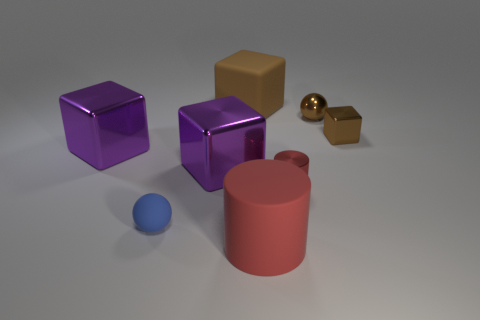Describe the lighting and atmosphere of this scene. The lighting in the scene is soft and diffuse, with no harsh shadows, suggesting an evenly lit indoor environment or a studio setup. This sort of lighting is often used to highlight details of objects without introducing glare or overshadowing. The atmosphere feels placid and neutral, hinting at a controlled setting tailored for displaying the objects' characteristics clearly, without any distracting elements. 